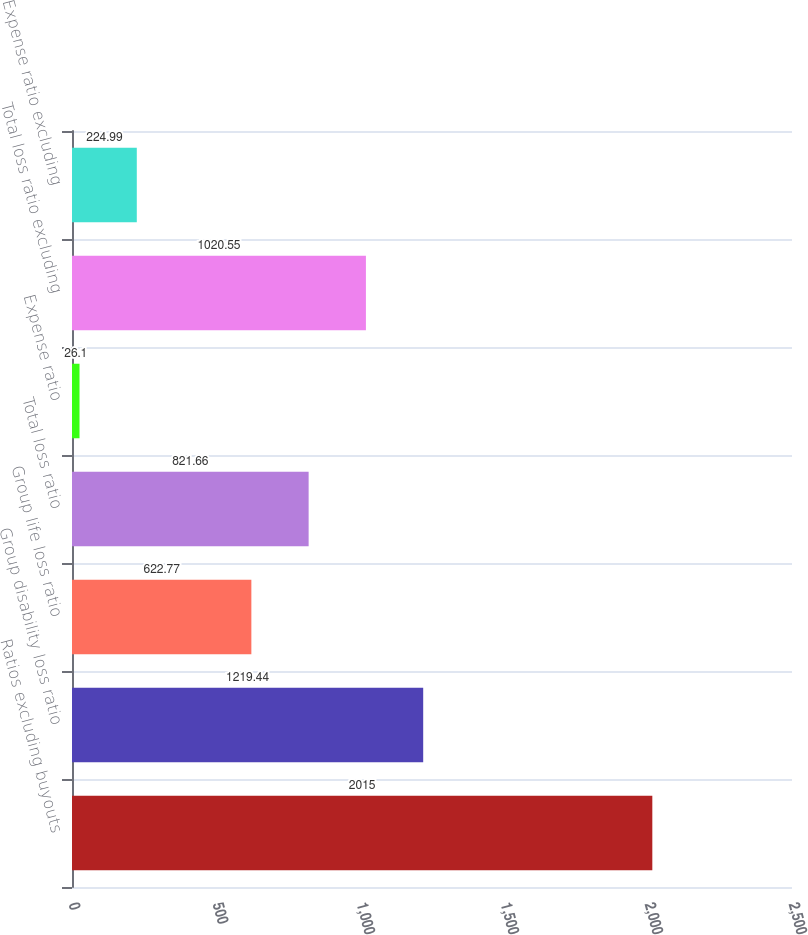Convert chart to OTSL. <chart><loc_0><loc_0><loc_500><loc_500><bar_chart><fcel>Ratios excluding buyouts<fcel>Group disability loss ratio<fcel>Group life loss ratio<fcel>Total loss ratio<fcel>Expense ratio<fcel>Total loss ratio excluding<fcel>Expense ratio excluding<nl><fcel>2015<fcel>1219.44<fcel>622.77<fcel>821.66<fcel>26.1<fcel>1020.55<fcel>224.99<nl></chart> 